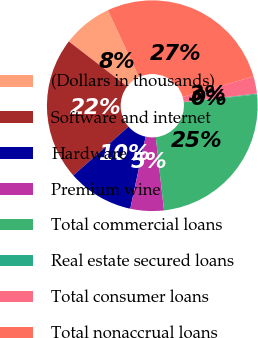Convert chart. <chart><loc_0><loc_0><loc_500><loc_500><pie_chart><fcel>(Dollars in thousands)<fcel>Software and internet<fcel>Hardware<fcel>Premium wine<fcel>Total commercial loans<fcel>Real estate secured loans<fcel>Total consumer loans<fcel>Total nonaccrual loans<nl><fcel>7.63%<fcel>21.95%<fcel>10.14%<fcel>5.13%<fcel>24.94%<fcel>0.13%<fcel>2.63%<fcel>27.45%<nl></chart> 